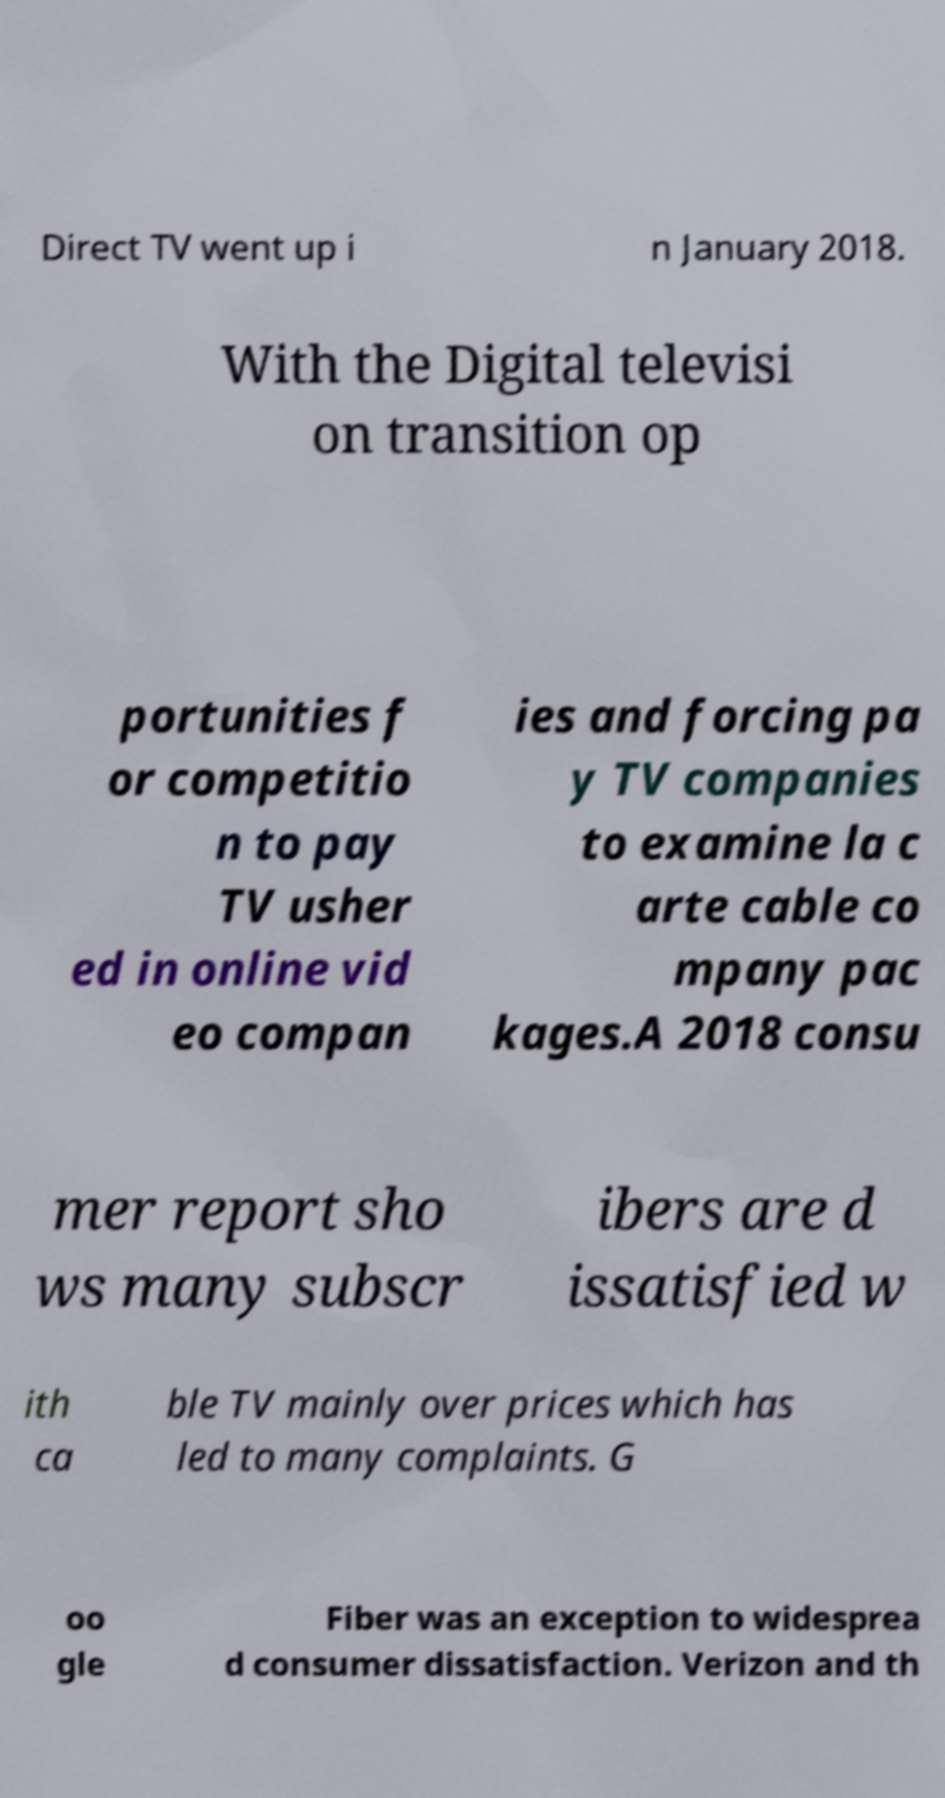Can you read and provide the text displayed in the image?This photo seems to have some interesting text. Can you extract and type it out for me? Direct TV went up i n January 2018. With the Digital televisi on transition op portunities f or competitio n to pay TV usher ed in online vid eo compan ies and forcing pa y TV companies to examine la c arte cable co mpany pac kages.A 2018 consu mer report sho ws many subscr ibers are d issatisfied w ith ca ble TV mainly over prices which has led to many complaints. G oo gle Fiber was an exception to widesprea d consumer dissatisfaction. Verizon and th 